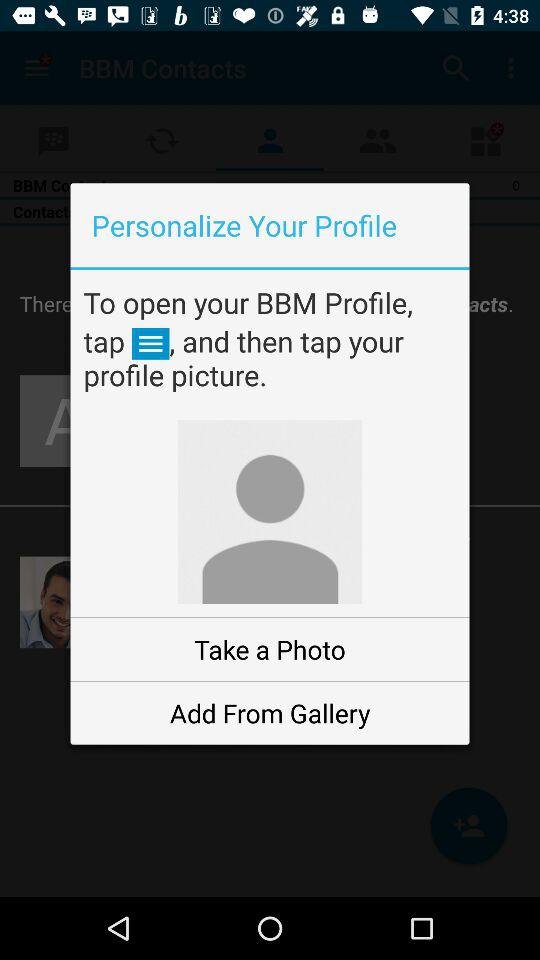How many steps are there to open your BBM profile?
Answer the question using a single word or phrase. 2 